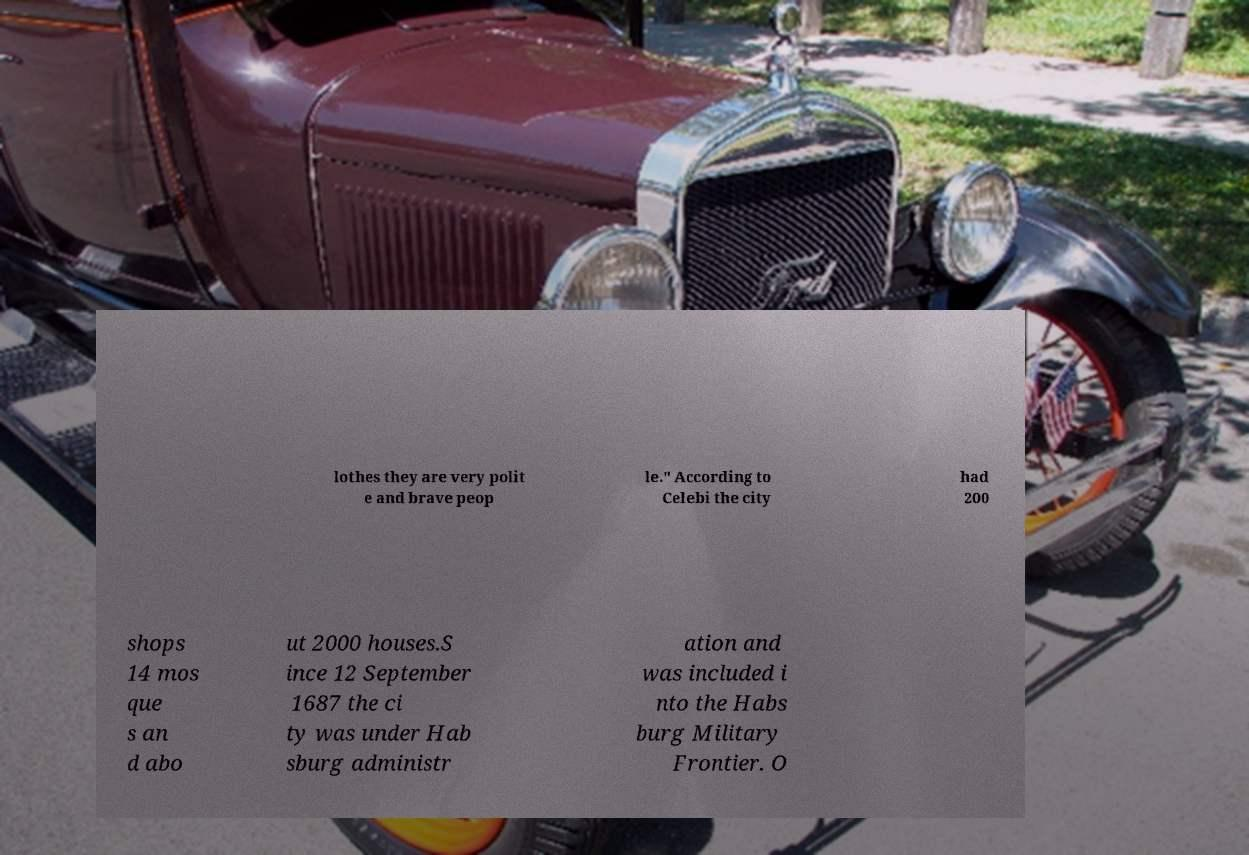I need the written content from this picture converted into text. Can you do that? lothes they are very polit e and brave peop le." According to Celebi the city had 200 shops 14 mos que s an d abo ut 2000 houses.S ince 12 September 1687 the ci ty was under Hab sburg administr ation and was included i nto the Habs burg Military Frontier. O 